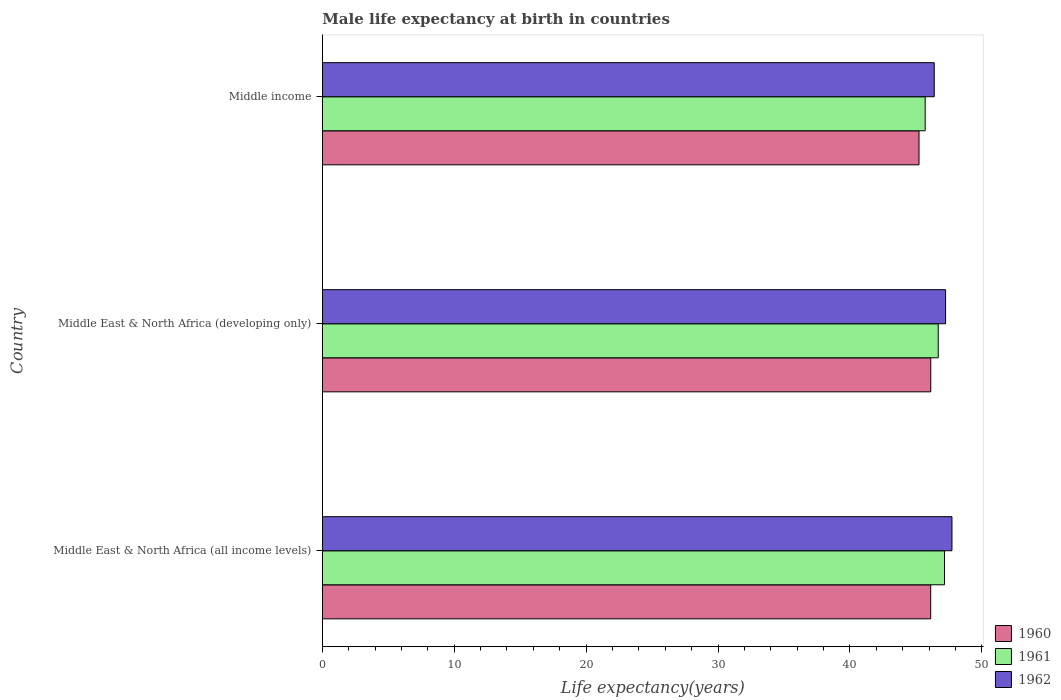Are the number of bars per tick equal to the number of legend labels?
Provide a short and direct response. Yes. How many bars are there on the 3rd tick from the bottom?
Offer a terse response. 3. What is the label of the 2nd group of bars from the top?
Your answer should be compact. Middle East & North Africa (developing only). What is the male life expectancy at birth in 1961 in Middle income?
Give a very brief answer. 45.71. Across all countries, what is the maximum male life expectancy at birth in 1962?
Your answer should be compact. 47.74. Across all countries, what is the minimum male life expectancy at birth in 1962?
Your answer should be compact. 46.39. In which country was the male life expectancy at birth in 1961 maximum?
Offer a terse response. Middle East & North Africa (all income levels). What is the total male life expectancy at birth in 1961 in the graph?
Provide a short and direct response. 139.57. What is the difference between the male life expectancy at birth in 1960 in Middle East & North Africa (developing only) and that in Middle income?
Offer a terse response. 0.89. What is the difference between the male life expectancy at birth in 1962 in Middle income and the male life expectancy at birth in 1960 in Middle East & North Africa (developing only)?
Your answer should be very brief. 0.26. What is the average male life expectancy at birth in 1961 per country?
Your response must be concise. 46.52. What is the difference between the male life expectancy at birth in 1960 and male life expectancy at birth in 1961 in Middle income?
Your answer should be very brief. -0.47. In how many countries, is the male life expectancy at birth in 1961 greater than 36 years?
Make the answer very short. 3. What is the ratio of the male life expectancy at birth in 1961 in Middle East & North Africa (all income levels) to that in Middle East & North Africa (developing only)?
Offer a very short reply. 1.01. Is the male life expectancy at birth in 1961 in Middle East & North Africa (all income levels) less than that in Middle income?
Offer a terse response. No. Is the difference between the male life expectancy at birth in 1960 in Middle East & North Africa (developing only) and Middle income greater than the difference between the male life expectancy at birth in 1961 in Middle East & North Africa (developing only) and Middle income?
Keep it short and to the point. No. What is the difference between the highest and the second highest male life expectancy at birth in 1962?
Give a very brief answer. 0.48. What is the difference between the highest and the lowest male life expectancy at birth in 1960?
Your answer should be very brief. 0.89. In how many countries, is the male life expectancy at birth in 1961 greater than the average male life expectancy at birth in 1961 taken over all countries?
Give a very brief answer. 2. What does the 2nd bar from the top in Middle income represents?
Your answer should be compact. 1961. What does the 1st bar from the bottom in Middle income represents?
Ensure brevity in your answer.  1960. How many bars are there?
Ensure brevity in your answer.  9. Are the values on the major ticks of X-axis written in scientific E-notation?
Keep it short and to the point. No. Does the graph contain any zero values?
Give a very brief answer. No. Where does the legend appear in the graph?
Your answer should be compact. Bottom right. How many legend labels are there?
Keep it short and to the point. 3. How are the legend labels stacked?
Provide a short and direct response. Vertical. What is the title of the graph?
Your answer should be very brief. Male life expectancy at birth in countries. What is the label or title of the X-axis?
Your answer should be compact. Life expectancy(years). What is the label or title of the Y-axis?
Offer a very short reply. Country. What is the Life expectancy(years) of 1960 in Middle East & North Africa (all income levels)?
Make the answer very short. 46.12. What is the Life expectancy(years) of 1961 in Middle East & North Africa (all income levels)?
Offer a terse response. 47.17. What is the Life expectancy(years) of 1962 in Middle East & North Africa (all income levels)?
Your answer should be compact. 47.74. What is the Life expectancy(years) in 1960 in Middle East & North Africa (developing only)?
Keep it short and to the point. 46.13. What is the Life expectancy(years) in 1961 in Middle East & North Africa (developing only)?
Keep it short and to the point. 46.69. What is the Life expectancy(years) of 1962 in Middle East & North Africa (developing only)?
Give a very brief answer. 47.25. What is the Life expectancy(years) of 1960 in Middle income?
Your answer should be compact. 45.24. What is the Life expectancy(years) in 1961 in Middle income?
Offer a terse response. 45.71. What is the Life expectancy(years) of 1962 in Middle income?
Provide a short and direct response. 46.39. Across all countries, what is the maximum Life expectancy(years) of 1960?
Provide a succinct answer. 46.13. Across all countries, what is the maximum Life expectancy(years) in 1961?
Give a very brief answer. 47.17. Across all countries, what is the maximum Life expectancy(years) of 1962?
Provide a succinct answer. 47.74. Across all countries, what is the minimum Life expectancy(years) in 1960?
Keep it short and to the point. 45.24. Across all countries, what is the minimum Life expectancy(years) of 1961?
Your answer should be compact. 45.71. Across all countries, what is the minimum Life expectancy(years) of 1962?
Keep it short and to the point. 46.39. What is the total Life expectancy(years) in 1960 in the graph?
Make the answer very short. 137.49. What is the total Life expectancy(years) of 1961 in the graph?
Make the answer very short. 139.57. What is the total Life expectancy(years) of 1962 in the graph?
Offer a terse response. 141.38. What is the difference between the Life expectancy(years) of 1960 in Middle East & North Africa (all income levels) and that in Middle East & North Africa (developing only)?
Offer a terse response. -0. What is the difference between the Life expectancy(years) of 1961 in Middle East & North Africa (all income levels) and that in Middle East & North Africa (developing only)?
Make the answer very short. 0.48. What is the difference between the Life expectancy(years) in 1962 in Middle East & North Africa (all income levels) and that in Middle East & North Africa (developing only)?
Your answer should be very brief. 0.48. What is the difference between the Life expectancy(years) in 1960 in Middle East & North Africa (all income levels) and that in Middle income?
Your response must be concise. 0.89. What is the difference between the Life expectancy(years) of 1961 in Middle East & North Africa (all income levels) and that in Middle income?
Give a very brief answer. 1.47. What is the difference between the Life expectancy(years) in 1962 in Middle East & North Africa (all income levels) and that in Middle income?
Provide a short and direct response. 1.34. What is the difference between the Life expectancy(years) in 1960 in Middle East & North Africa (developing only) and that in Middle income?
Your answer should be compact. 0.89. What is the difference between the Life expectancy(years) in 1961 in Middle East & North Africa (developing only) and that in Middle income?
Keep it short and to the point. 0.99. What is the difference between the Life expectancy(years) in 1962 in Middle East & North Africa (developing only) and that in Middle income?
Provide a succinct answer. 0.86. What is the difference between the Life expectancy(years) of 1960 in Middle East & North Africa (all income levels) and the Life expectancy(years) of 1961 in Middle East & North Africa (developing only)?
Your response must be concise. -0.57. What is the difference between the Life expectancy(years) in 1960 in Middle East & North Africa (all income levels) and the Life expectancy(years) in 1962 in Middle East & North Africa (developing only)?
Your response must be concise. -1.13. What is the difference between the Life expectancy(years) in 1961 in Middle East & North Africa (all income levels) and the Life expectancy(years) in 1962 in Middle East & North Africa (developing only)?
Offer a terse response. -0.08. What is the difference between the Life expectancy(years) of 1960 in Middle East & North Africa (all income levels) and the Life expectancy(years) of 1961 in Middle income?
Make the answer very short. 0.42. What is the difference between the Life expectancy(years) of 1960 in Middle East & North Africa (all income levels) and the Life expectancy(years) of 1962 in Middle income?
Provide a succinct answer. -0.27. What is the difference between the Life expectancy(years) in 1961 in Middle East & North Africa (all income levels) and the Life expectancy(years) in 1962 in Middle income?
Provide a short and direct response. 0.78. What is the difference between the Life expectancy(years) in 1960 in Middle East & North Africa (developing only) and the Life expectancy(years) in 1961 in Middle income?
Give a very brief answer. 0.42. What is the difference between the Life expectancy(years) of 1960 in Middle East & North Africa (developing only) and the Life expectancy(years) of 1962 in Middle income?
Ensure brevity in your answer.  -0.26. What is the difference between the Life expectancy(years) of 1961 in Middle East & North Africa (developing only) and the Life expectancy(years) of 1962 in Middle income?
Your answer should be compact. 0.3. What is the average Life expectancy(years) of 1960 per country?
Provide a short and direct response. 45.83. What is the average Life expectancy(years) of 1961 per country?
Your response must be concise. 46.52. What is the average Life expectancy(years) of 1962 per country?
Keep it short and to the point. 47.13. What is the difference between the Life expectancy(years) of 1960 and Life expectancy(years) of 1961 in Middle East & North Africa (all income levels)?
Offer a very short reply. -1.05. What is the difference between the Life expectancy(years) of 1960 and Life expectancy(years) of 1962 in Middle East & North Africa (all income levels)?
Ensure brevity in your answer.  -1.61. What is the difference between the Life expectancy(years) of 1961 and Life expectancy(years) of 1962 in Middle East & North Africa (all income levels)?
Provide a short and direct response. -0.56. What is the difference between the Life expectancy(years) of 1960 and Life expectancy(years) of 1961 in Middle East & North Africa (developing only)?
Provide a succinct answer. -0.56. What is the difference between the Life expectancy(years) in 1960 and Life expectancy(years) in 1962 in Middle East & North Africa (developing only)?
Make the answer very short. -1.12. What is the difference between the Life expectancy(years) in 1961 and Life expectancy(years) in 1962 in Middle East & North Africa (developing only)?
Keep it short and to the point. -0.56. What is the difference between the Life expectancy(years) of 1960 and Life expectancy(years) of 1961 in Middle income?
Your answer should be very brief. -0.47. What is the difference between the Life expectancy(years) in 1960 and Life expectancy(years) in 1962 in Middle income?
Your response must be concise. -1.15. What is the difference between the Life expectancy(years) of 1961 and Life expectancy(years) of 1962 in Middle income?
Your answer should be compact. -0.69. What is the ratio of the Life expectancy(years) in 1961 in Middle East & North Africa (all income levels) to that in Middle East & North Africa (developing only)?
Provide a succinct answer. 1.01. What is the ratio of the Life expectancy(years) of 1962 in Middle East & North Africa (all income levels) to that in Middle East & North Africa (developing only)?
Give a very brief answer. 1.01. What is the ratio of the Life expectancy(years) of 1960 in Middle East & North Africa (all income levels) to that in Middle income?
Offer a very short reply. 1.02. What is the ratio of the Life expectancy(years) of 1961 in Middle East & North Africa (all income levels) to that in Middle income?
Provide a succinct answer. 1.03. What is the ratio of the Life expectancy(years) of 1962 in Middle East & North Africa (all income levels) to that in Middle income?
Make the answer very short. 1.03. What is the ratio of the Life expectancy(years) in 1960 in Middle East & North Africa (developing only) to that in Middle income?
Keep it short and to the point. 1.02. What is the ratio of the Life expectancy(years) in 1961 in Middle East & North Africa (developing only) to that in Middle income?
Provide a succinct answer. 1.02. What is the ratio of the Life expectancy(years) of 1962 in Middle East & North Africa (developing only) to that in Middle income?
Ensure brevity in your answer.  1.02. What is the difference between the highest and the second highest Life expectancy(years) of 1960?
Make the answer very short. 0. What is the difference between the highest and the second highest Life expectancy(years) in 1961?
Provide a short and direct response. 0.48. What is the difference between the highest and the second highest Life expectancy(years) of 1962?
Provide a succinct answer. 0.48. What is the difference between the highest and the lowest Life expectancy(years) of 1960?
Give a very brief answer. 0.89. What is the difference between the highest and the lowest Life expectancy(years) of 1961?
Your answer should be compact. 1.47. What is the difference between the highest and the lowest Life expectancy(years) of 1962?
Your answer should be compact. 1.34. 